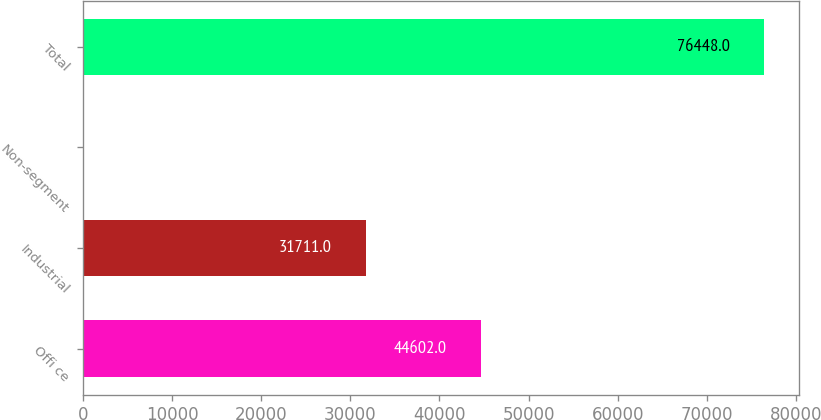Convert chart to OTSL. <chart><loc_0><loc_0><loc_500><loc_500><bar_chart><fcel>Offi ce<fcel>Industrial<fcel>Non-segment<fcel>Total<nl><fcel>44602<fcel>31711<fcel>135<fcel>76448<nl></chart> 